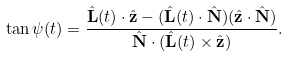<formula> <loc_0><loc_0><loc_500><loc_500>\tan \psi ( t ) = \frac { \hat { \mathbf L } ( t ) \cdot \hat { \mathbf z } - ( \hat { \mathbf L } ( t ) \cdot \hat { \mathbf N } ) ( \hat { \mathbf z } \cdot \hat { \mathbf N } ) } { \hat { \mathbf N } \cdot ( \hat { \mathbf L } ( t ) \times \hat { \mathbf z } ) } .</formula> 